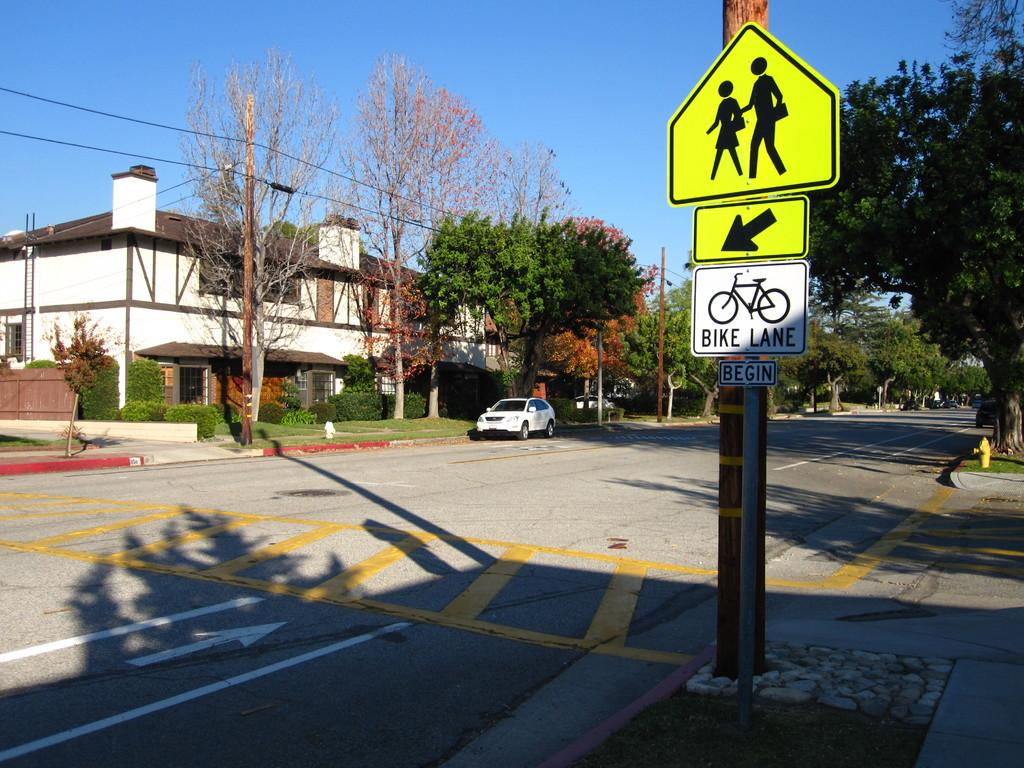<image>
Render a clear and concise summary of the photo. A road sign displays information pertaining to where the Bike Lane begins. 